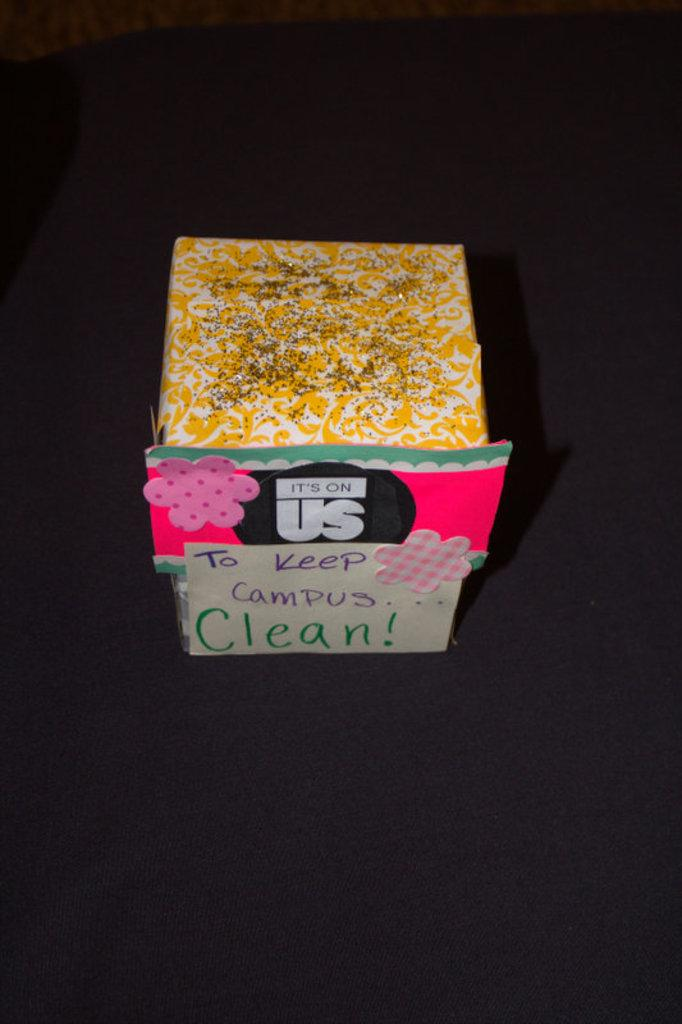<image>
Summarize the visual content of the image. A box covered with different patterned papers encourages people to keep the campus clean. 